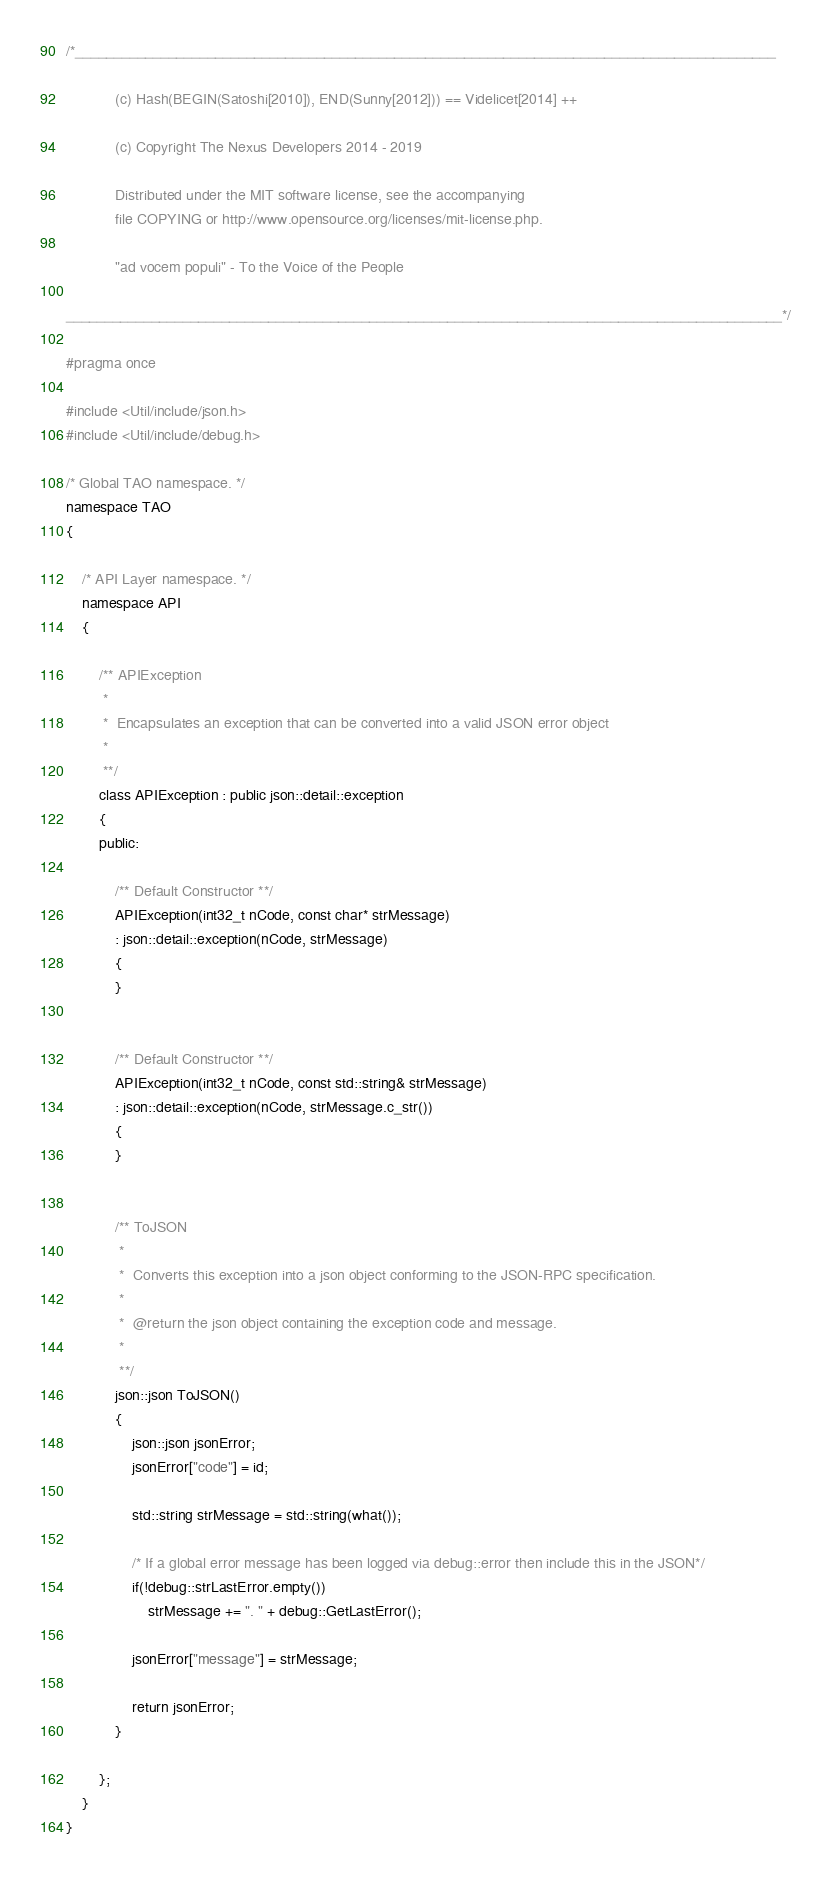Convert code to text. <code><loc_0><loc_0><loc_500><loc_500><_C_>/*__________________________________________________________________________________________

            (c) Hash(BEGIN(Satoshi[2010]), END(Sunny[2012])) == Videlicet[2014] ++

            (c) Copyright The Nexus Developers 2014 - 2019

            Distributed under the MIT software license, see the accompanying
            file COPYING or http://www.opensource.org/licenses/mit-license.php.

            "ad vocem populi" - To the Voice of the People

____________________________________________________________________________________________*/

#pragma once

#include <Util/include/json.h>
#include <Util/include/debug.h>

/* Global TAO namespace. */
namespace TAO
{

    /* API Layer namespace. */
    namespace API
    {

        /** APIException
         *
         *  Encapsulates an exception that can be converted into a valid JSON error object
         *
         **/
        class APIException : public json::detail::exception
        {
        public:

            /** Default Constructor **/
            APIException(int32_t nCode, const char* strMessage)
            : json::detail::exception(nCode, strMessage)
            {
            }


            /** Default Constructor **/
            APIException(int32_t nCode, const std::string& strMessage)
            : json::detail::exception(nCode, strMessage.c_str())
            {
            }


            /** ToJSON
             *
             *  Converts this exception into a json object conforming to the JSON-RPC specification.
             *
             *  @return the json object containing the exception code and message.
             *
             **/
            json::json ToJSON()
            {
                json::json jsonError;
                jsonError["code"] = id;

                std::string strMessage = std::string(what());

                /* If a global error message has been logged via debug::error then include this in the JSON*/
                if(!debug::strLastError.empty())
                    strMessage += ". " + debug::GetLastError();

                jsonError["message"] = strMessage;

                return jsonError;
            }

        };
    }
}
</code> 